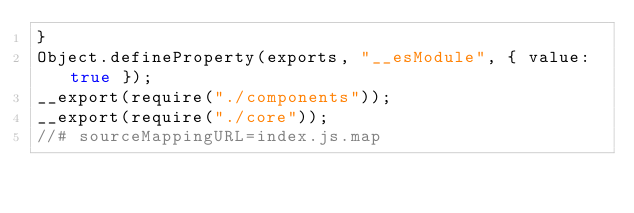<code> <loc_0><loc_0><loc_500><loc_500><_JavaScript_>}
Object.defineProperty(exports, "__esModule", { value: true });
__export(require("./components"));
__export(require("./core"));
//# sourceMappingURL=index.js.map</code> 